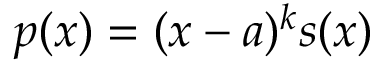Convert formula to latex. <formula><loc_0><loc_0><loc_500><loc_500>p ( x ) = ( x - a ) ^ { k } s ( x )</formula> 